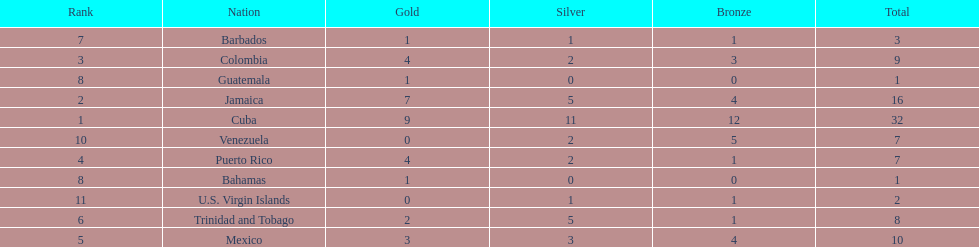Could you help me parse every detail presented in this table? {'header': ['Rank', 'Nation', 'Gold', 'Silver', 'Bronze', 'Total'], 'rows': [['7', 'Barbados', '1', '1', '1', '3'], ['3', 'Colombia', '4', '2', '3', '9'], ['8', 'Guatemala', '1', '0', '0', '1'], ['2', 'Jamaica', '7', '5', '4', '16'], ['1', 'Cuba', '9', '11', '12', '32'], ['10', 'Venezuela', '0', '2', '5', '7'], ['4', 'Puerto Rico', '4', '2', '1', '7'], ['8', 'Bahamas', '1', '0', '0', '1'], ['11', 'U.S. Virgin Islands', '0', '1', '1', '2'], ['6', 'Trinidad and Tobago', '2', '5', '1', '8'], ['5', 'Mexico', '3', '3', '4', '10']]} Largest medal differential between countries 31. 